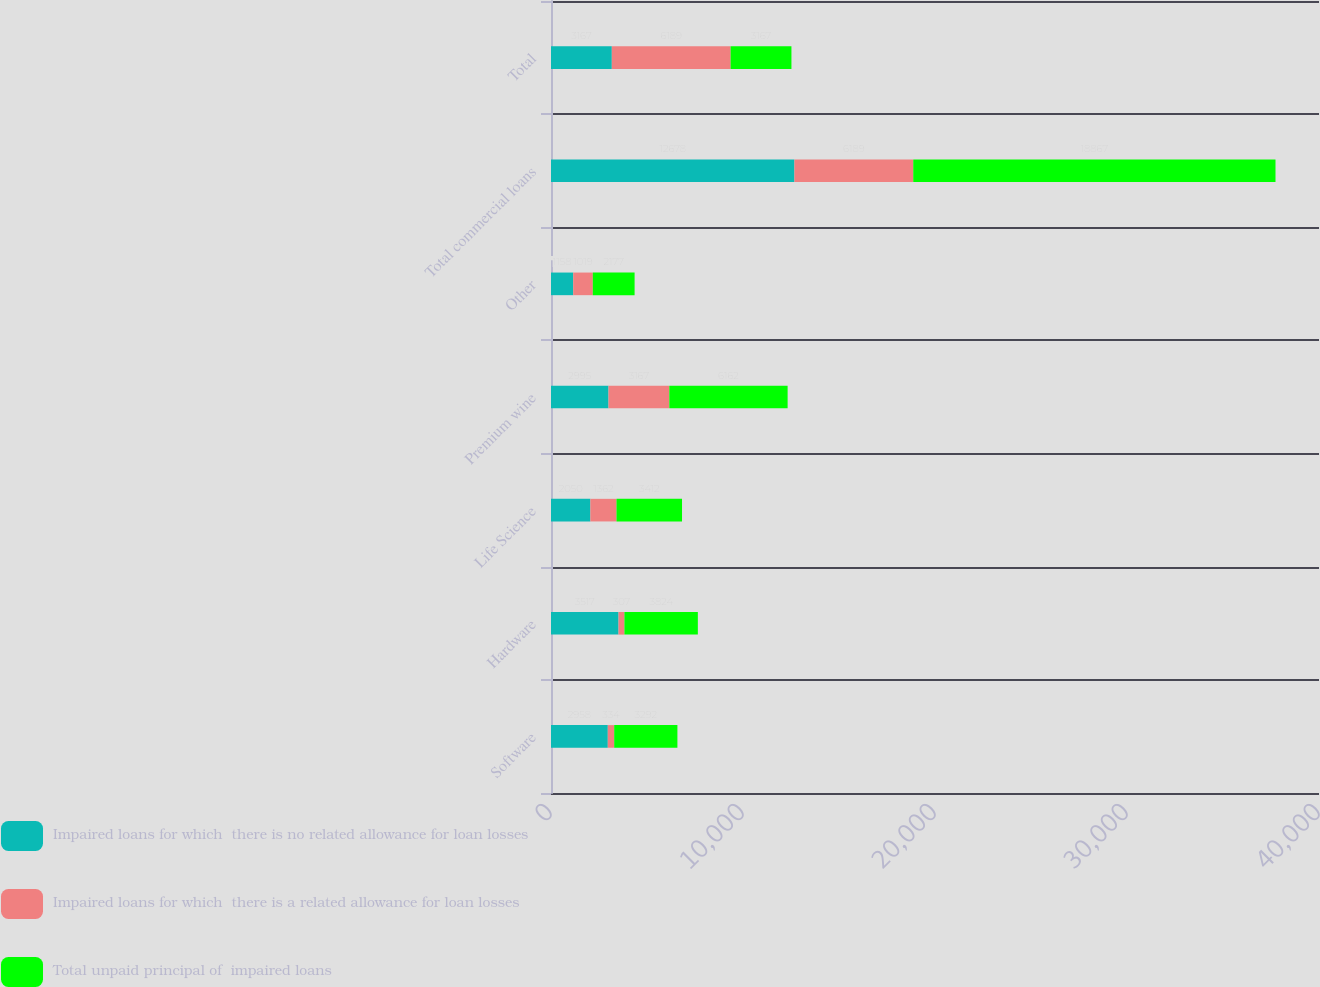Convert chart to OTSL. <chart><loc_0><loc_0><loc_500><loc_500><stacked_bar_chart><ecel><fcel>Software<fcel>Hardware<fcel>Life Science<fcel>Premium wine<fcel>Other<fcel>Total commercial loans<fcel>Total<nl><fcel>Impaired loans for which  there is no related allowance for loan losses<fcel>2958<fcel>3517<fcel>2050<fcel>2995<fcel>1158<fcel>12678<fcel>3167<nl><fcel>Impaired loans for which  there is a related allowance for loan losses<fcel>334<fcel>307<fcel>1362<fcel>3167<fcel>1019<fcel>6189<fcel>6189<nl><fcel>Total unpaid principal of  impaired loans<fcel>3292<fcel>3824<fcel>3412<fcel>6162<fcel>2177<fcel>18867<fcel>3167<nl></chart> 